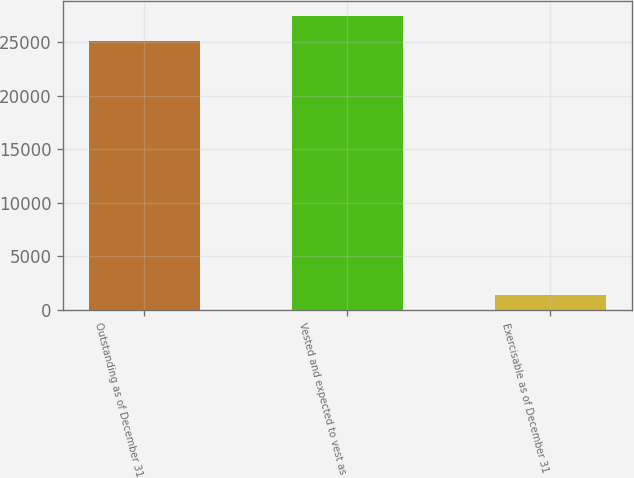<chart> <loc_0><loc_0><loc_500><loc_500><bar_chart><fcel>Outstanding as of December 31<fcel>Vested and expected to vest as<fcel>Exercisable as of December 31<nl><fcel>25110<fcel>27480.2<fcel>1408<nl></chart> 